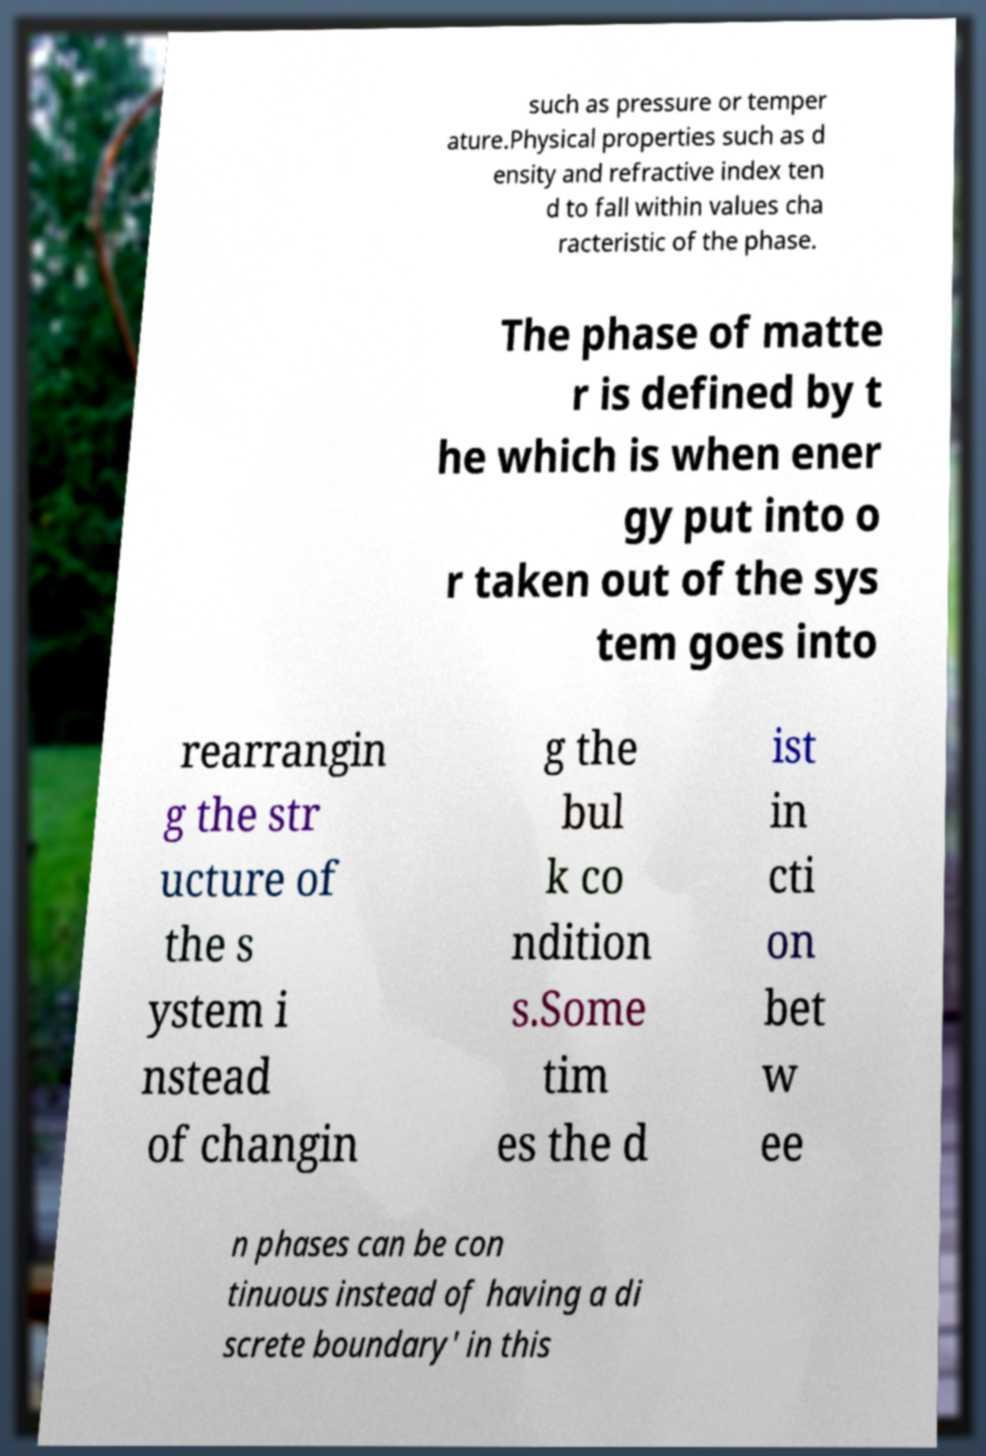Please read and relay the text visible in this image. What does it say? such as pressure or temper ature.Physical properties such as d ensity and refractive index ten d to fall within values cha racteristic of the phase. The phase of matte r is defined by t he which is when ener gy put into o r taken out of the sys tem goes into rearrangin g the str ucture of the s ystem i nstead of changin g the bul k co ndition s.Some tim es the d ist in cti on bet w ee n phases can be con tinuous instead of having a di screte boundary' in this 